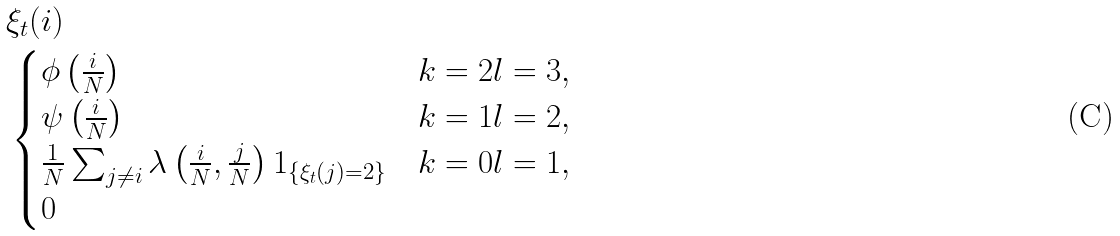Convert formula to latex. <formula><loc_0><loc_0><loc_500><loc_500>& \xi _ { t } ( i ) \\ & \begin{cases} \phi \left ( \frac { i } { N } \right ) & k = 2 l = 3 , \\ \psi \left ( \frac { i } { N } \right ) & k = 1 l = 2 , \\ \frac { 1 } { N } \sum _ { j \neq i } \lambda \left ( \frac { i } { N } , \frac { j } { N } \right ) 1 _ { \{ \xi _ { t } ( j ) = 2 \} } & k = 0 l = 1 , \\ 0 & \end{cases}</formula> 